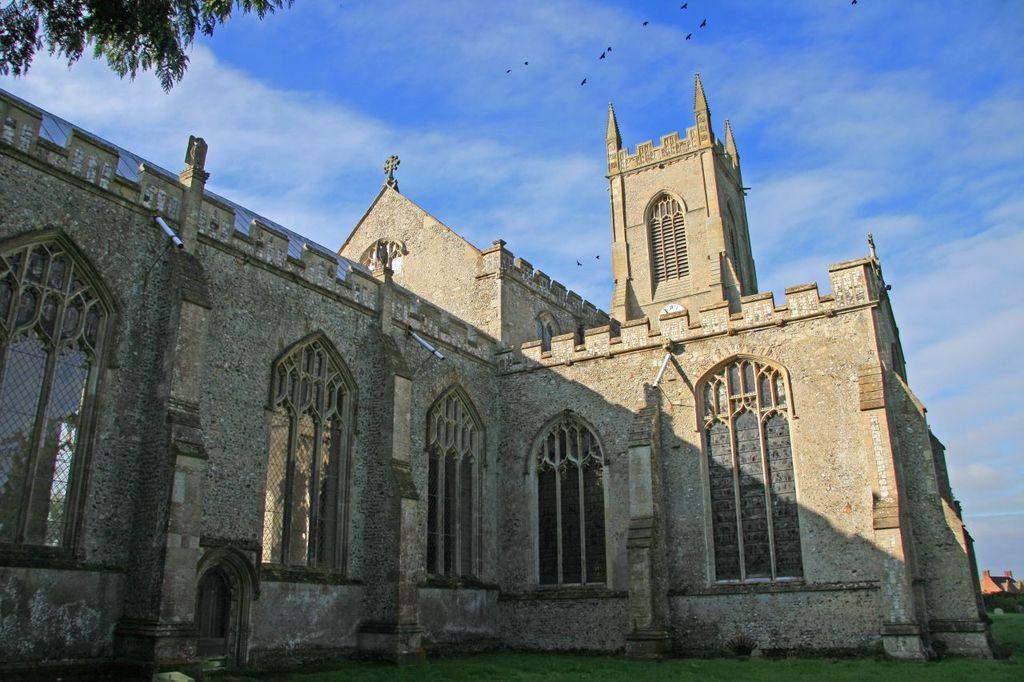What type of building is in the image? There is a bungalow in the image. What features can be seen on the bungalow? The bungalow has walls, grills, and pillars. What is visible at the bottom of the image? There is grass at the bottom of the image. What is visible at the top of the image? The sky is visible at the top of the image. What can be seen in the sky? There are birds and leaves visible in the sky. What type of engine is powering the bungalow in the image? There is no engine present in the image, as the bungalow is a stationary building. How many bulbs are visible in the image? There is no mention of bulbs in the provided facts, so it cannot be determined from the image. 